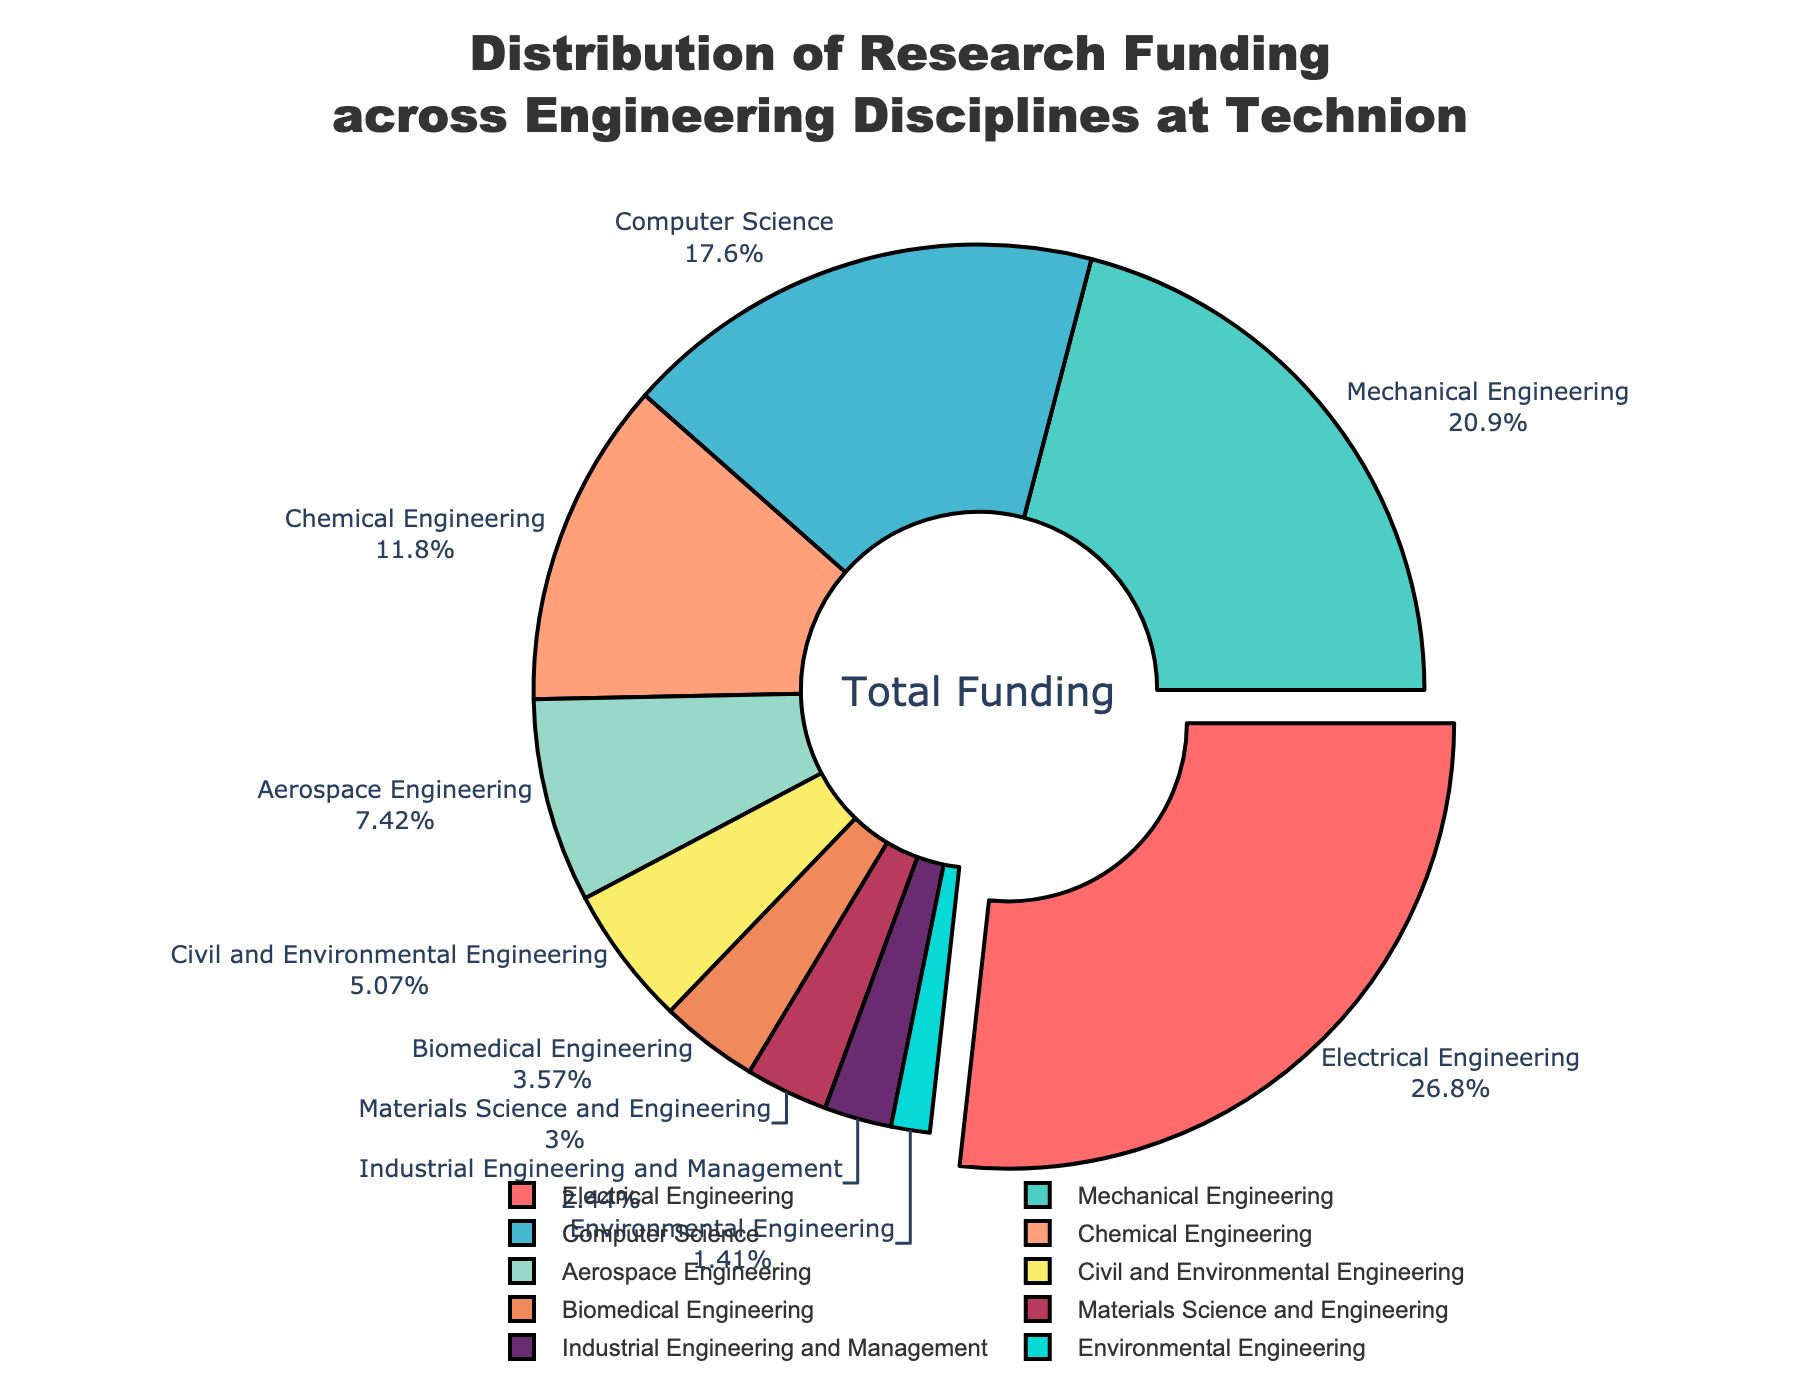Which discipline receives the highest percentage of research funding? Upon observing the pie chart, Electrical Engineering has the largest segment of funding, which is also pulled out for emphasis. Its percentage is 28.5%, the highest among all the disciplines.
Answer: Electrical Engineering Which two disciplines have the closest funding percentages? The two disciplines with the closest funding percentages are Industrial Engineering and Management (2.6%) and Environmental Engineering (1.5%). Their difference is 1.1%, which is less compared to any other pair of disciplines.
Answer: Industrial Engineering and Management and Environmental Engineering How much more funding does Electrical Engineering receive compared to Mechanical Engineering? According to the chart, Electrical Engineering receives 28.5% of the funding, while Mechanical Engineering gets 22.3%. Subtracting Mechanical Engineering’s share from Electrical Engineering’s share, we get 28.5% - 22.3% = 6.2%.
Answer: 6.2% What is the combined funding percentage for Aerospace Engineering and Civil and Environmental Engineering? The pie chart shows that Aerospace Engineering receives 7.9% of the funding and Civil and Environmental Engineering gets 5.4%. Summing these percentages, we get 7.9% + 5.4% = 13.3%.
Answer: 13.3% Which discipline has the smallest percentage of research funding, and what is its percentage? From the pie chart, Environmental Engineering is displayed with the smallest slice, indicating the lowest funding percentage at 1.5%.
Answer: Environmental Engineering, 1.5% How does the funding percentage for Biomedical Engineering compare to that of Materials Science and Engineering? Biomedical Engineering is allocated 3.8% of the funding, whereas Materials Science and Engineering receives 3.2%. Comparing these, Biomedical Engineering has 0.6% more funding than Materials Science and Engineering.
Answer: Biomedical Engineering has 0.6% more Which disciplines together make up more than half of the total research funding? To determine this, we add the funding percentages of disciplines until they exceed 50%. Electrical Engineering (28.5%), Mechanical Engineering (22.3%), and Computer Science (18.7%) together make 28.5% + 22.3% + 18.7% = 69.5%, which is more than half.
Answer: Electrical Engineering, Mechanical Engineering, and Computer Science If the total funding is $10 million, how much funding does Biomedical Engineering receive in dollars? Biomedical Engineering receives 3.8% of the total funding. To find the dollar amount: 3.8% of $10 million equals 0.038 * 10,000,000 = $380,000.
Answer: $380,000 